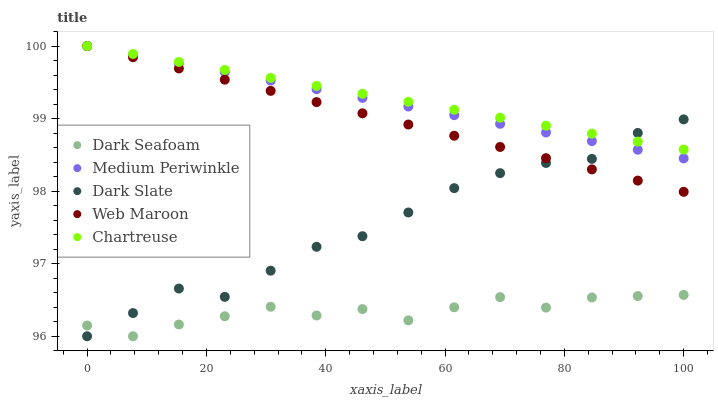Does Dark Seafoam have the minimum area under the curve?
Answer yes or no. Yes. Does Chartreuse have the maximum area under the curve?
Answer yes or no. Yes. Does Medium Periwinkle have the minimum area under the curve?
Answer yes or no. No. Does Medium Periwinkle have the maximum area under the curve?
Answer yes or no. No. Is Web Maroon the smoothest?
Answer yes or no. Yes. Is Dark Seafoam the roughest?
Answer yes or no. Yes. Is Medium Periwinkle the smoothest?
Answer yes or no. No. Is Medium Periwinkle the roughest?
Answer yes or no. No. Does Dark Slate have the lowest value?
Answer yes or no. Yes. Does Medium Periwinkle have the lowest value?
Answer yes or no. No. Does Web Maroon have the highest value?
Answer yes or no. Yes. Does Dark Seafoam have the highest value?
Answer yes or no. No. Is Dark Seafoam less than Web Maroon?
Answer yes or no. Yes. Is Medium Periwinkle greater than Dark Seafoam?
Answer yes or no. Yes. Does Chartreuse intersect Medium Periwinkle?
Answer yes or no. Yes. Is Chartreuse less than Medium Periwinkle?
Answer yes or no. No. Is Chartreuse greater than Medium Periwinkle?
Answer yes or no. No. Does Dark Seafoam intersect Web Maroon?
Answer yes or no. No. 